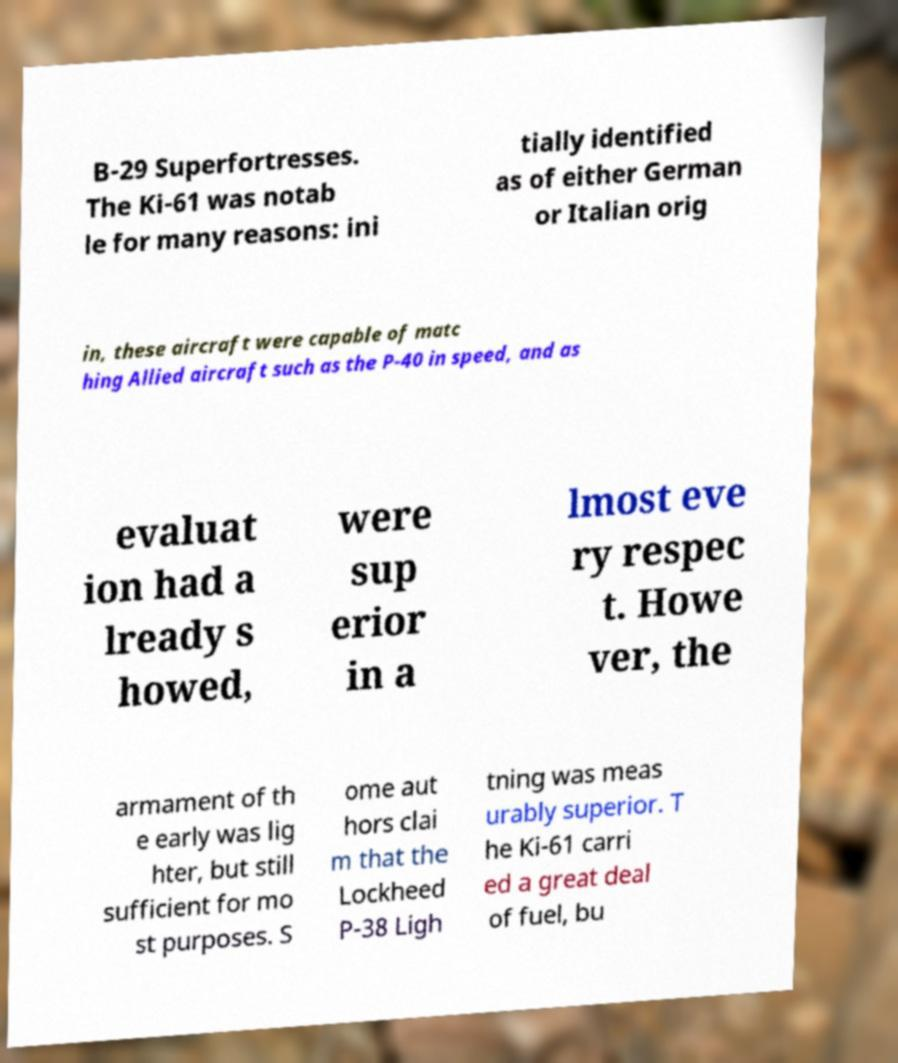What messages or text are displayed in this image? I need them in a readable, typed format. B-29 Superfortresses. The Ki-61 was notab le for many reasons: ini tially identified as of either German or Italian orig in, these aircraft were capable of matc hing Allied aircraft such as the P-40 in speed, and as evaluat ion had a lready s howed, were sup erior in a lmost eve ry respec t. Howe ver, the armament of th e early was lig hter, but still sufficient for mo st purposes. S ome aut hors clai m that the Lockheed P-38 Ligh tning was meas urably superior. T he Ki-61 carri ed a great deal of fuel, bu 